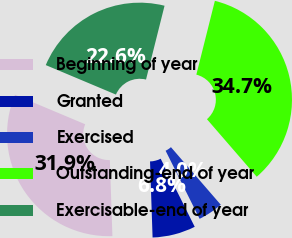Convert chart to OTSL. <chart><loc_0><loc_0><loc_500><loc_500><pie_chart><fcel>Beginning of year<fcel>Granted<fcel>Exercised<fcel>Outstanding-end of year<fcel>Exercisable-end of year<nl><fcel>31.87%<fcel>6.84%<fcel>3.98%<fcel>34.73%<fcel>22.58%<nl></chart> 